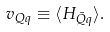<formula> <loc_0><loc_0><loc_500><loc_500>v _ { Q q } \equiv \langle H _ { \bar { Q } q } \rangle .</formula> 